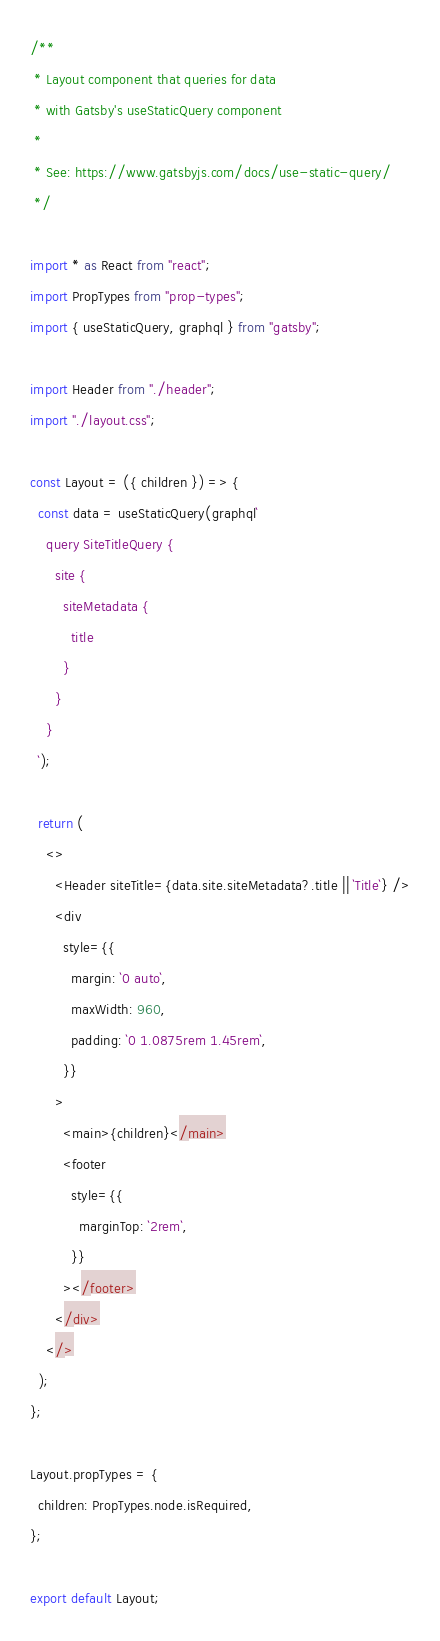<code> <loc_0><loc_0><loc_500><loc_500><_JavaScript_>/**
 * Layout component that queries for data
 * with Gatsby's useStaticQuery component
 *
 * See: https://www.gatsbyjs.com/docs/use-static-query/
 */

import * as React from "react";
import PropTypes from "prop-types";
import { useStaticQuery, graphql } from "gatsby";

import Header from "./header";
import "./layout.css";

const Layout = ({ children }) => {
  const data = useStaticQuery(graphql`
    query SiteTitleQuery {
      site {
        siteMetadata {
          title
        }
      }
    }
  `);

  return (
    <>
      <Header siteTitle={data.site.siteMetadata?.title || `Title`} />
      <div
        style={{
          margin: `0 auto`,
          maxWidth: 960,
          padding: `0 1.0875rem 1.45rem`,
        }}
      >
        <main>{children}</main>
        <footer
          style={{
            marginTop: `2rem`,
          }}
        ></footer>
      </div>
    </>
  );
};

Layout.propTypes = {
  children: PropTypes.node.isRequired,
};

export default Layout;
</code> 